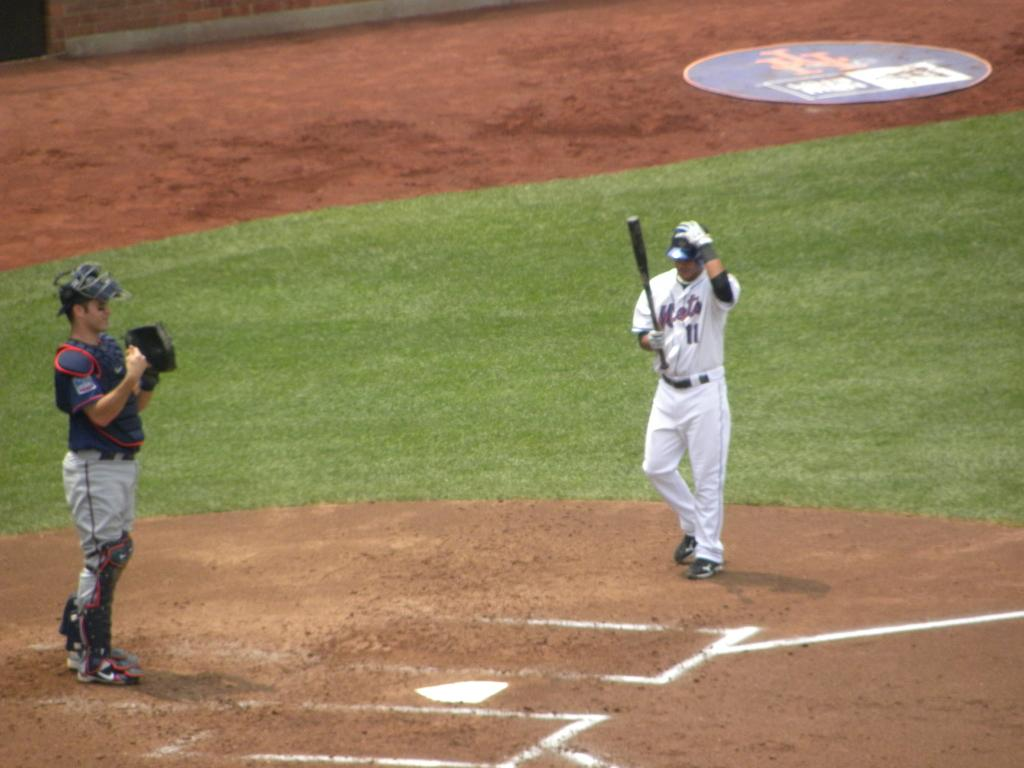How many people are in total are in the image? There are two persons standing on the ground in the image. What is one of the persons holding? One person is holding a baseball bat. What can be seen in the background of the image? There is a board on the ground in the background. How many tomatoes are on the front of the board in the image? There are no tomatoes present in the image, and the board does not have any tomatoes on it. 